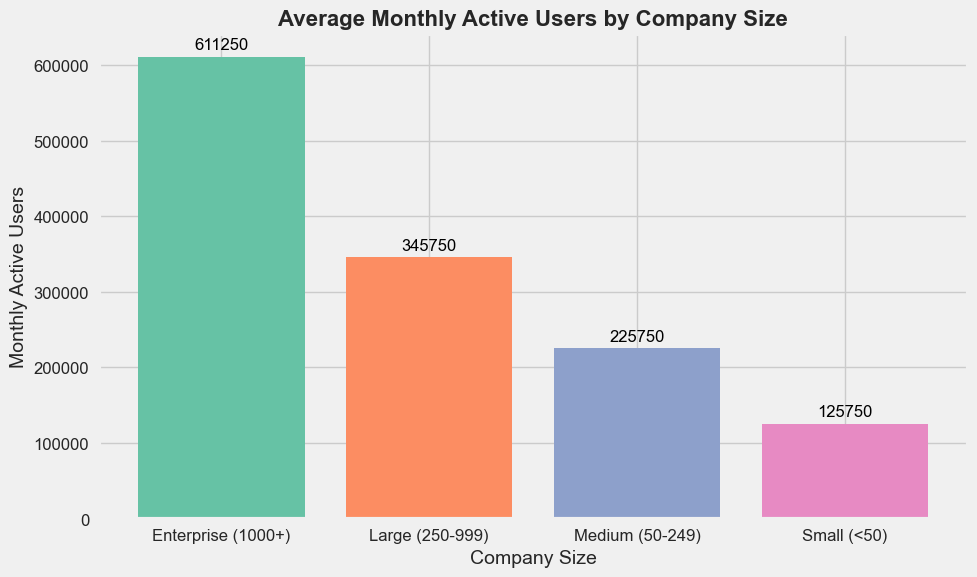Which company size has the highest average monthly active users? Looking at the height of the bars, the "Enterprise (1000+)" company size has the tallest bar, indicating the highest average monthly active users.
Answer: Enterprise (1000+) What is the average number of monthly active users in medium-sized companies (50-249)? Referring to the specific bar for "Medium (50-249)" companies, the numeric label on top of the bar provides this figure.
Answer: 225,750 How many more average monthly active users do large companies (250-999) have compared to small companies (<50)? Calculate the difference between the height of the "Large (250-999)" bar and the "Small (<50)" bar. Large companies have 345,000 users, and small companies have 125,750 users, so the difference is 345,000 - 125,750.
Answer: 219,250 Is the number of average monthly active users of medium-sized companies more or less than 230,000? Look at the height of the bar for "Medium (50-249)" companies. The value 225,750 is clearly below 230,000.
Answer: Less Compare the number of average monthly active users between large (250-999) and enterprise (1000+) companies. Which is higher and by how much? Compare the bar heights: Large has 345,000 and Enterprise has 611,250. The difference is 611,250 - 345,000.
Answer: Enterprise, by 266,250 What's the total average number of monthly active users across all company sizes? Sum the average users from all company sizes: 125,750 (Small) + 225,750 (Medium) + 345,000 (Large) + 611,250 (Enterprise).
Answer: 1,307,750 By what percentage does the average number of monthly active users in enterprise companies exceed those in small companies? Calculate the percentage increase: ((611,250 - 125,750) / 125,750) * 100%.
Answer: 386% What color represents the bar for small companies? Visually identify the color associated with the "Small (<50)" bar based on the bar colors.
Answer: Green Are medium-sized companies' average monthly active users closer to those of small or large companies? Compare the height difference. Medium to Small: 225,750 - 125,750 = 100,000. Medium to Large: 345,000 - 225,750 = 119,250.
Answer: Small 